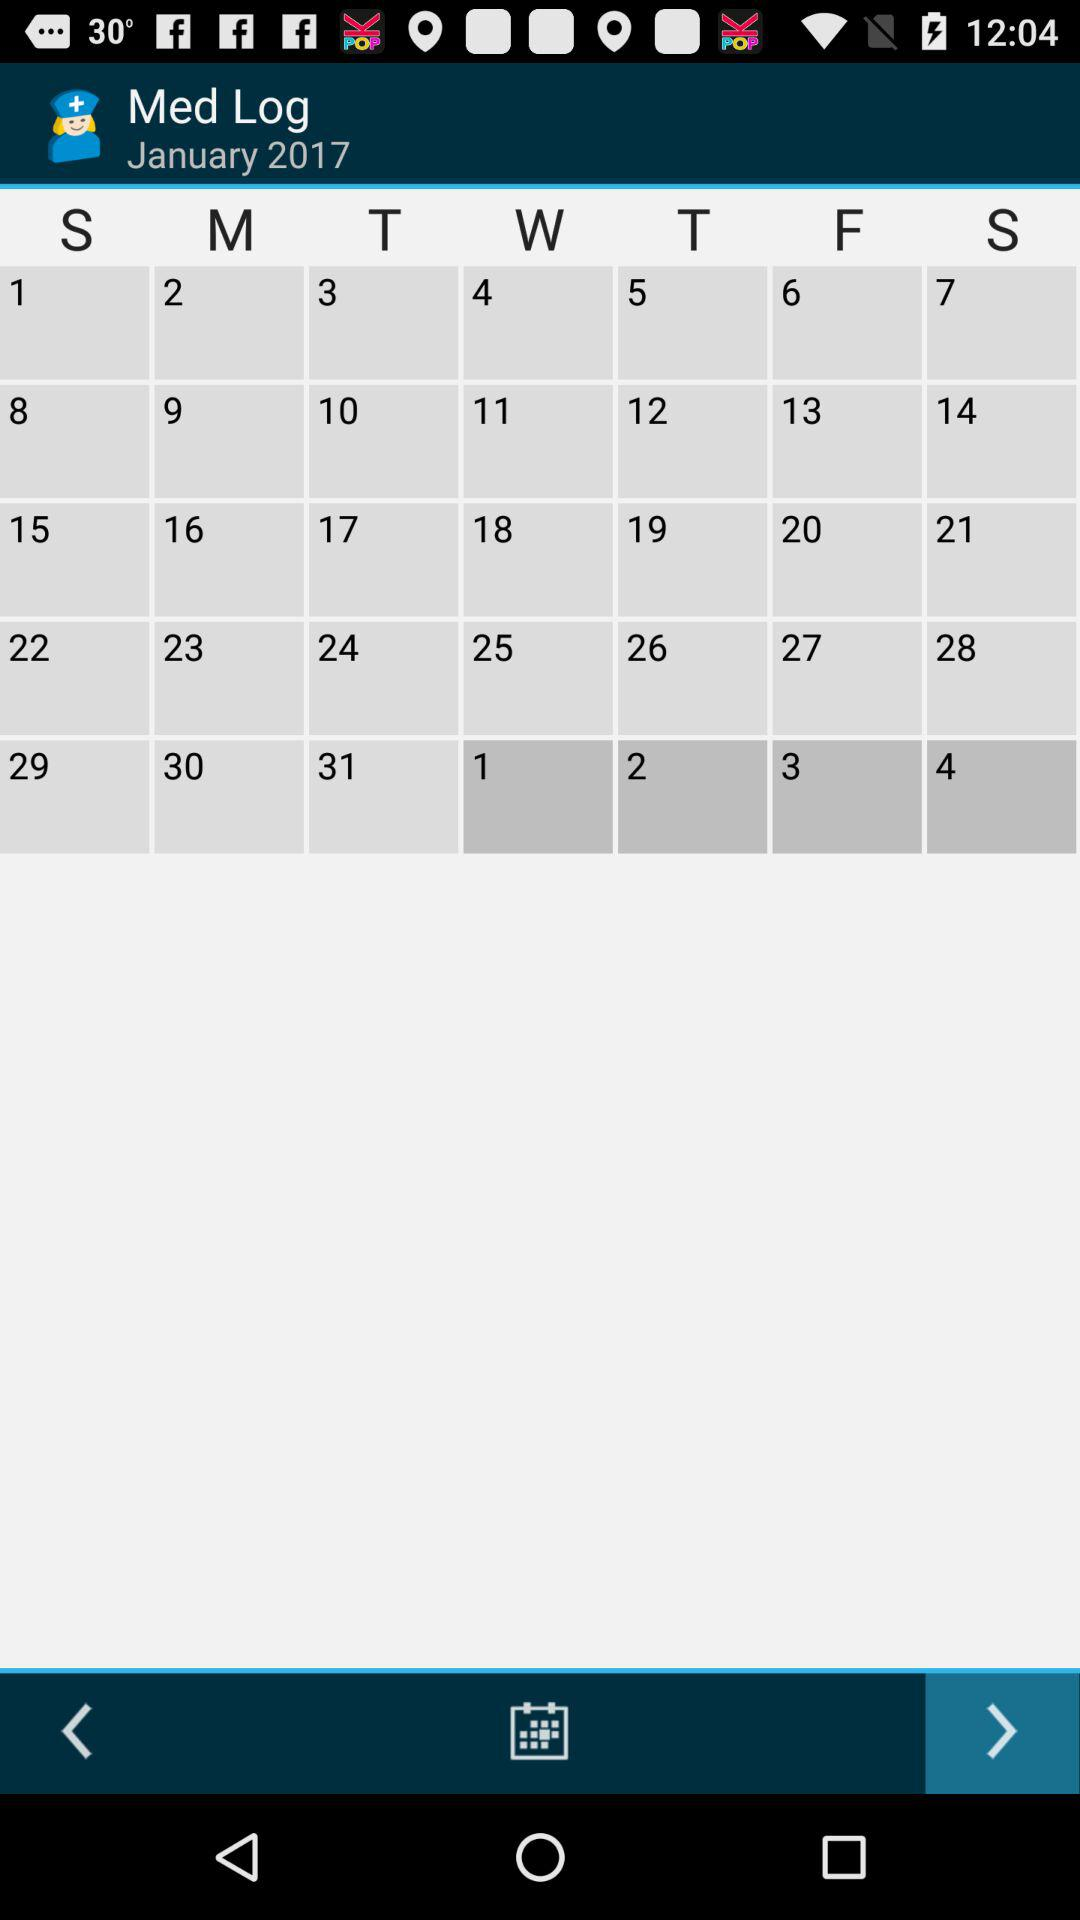What are the selected date on the calendar?
When the provided information is insufficient, respond with <no answer>. <no answer> 